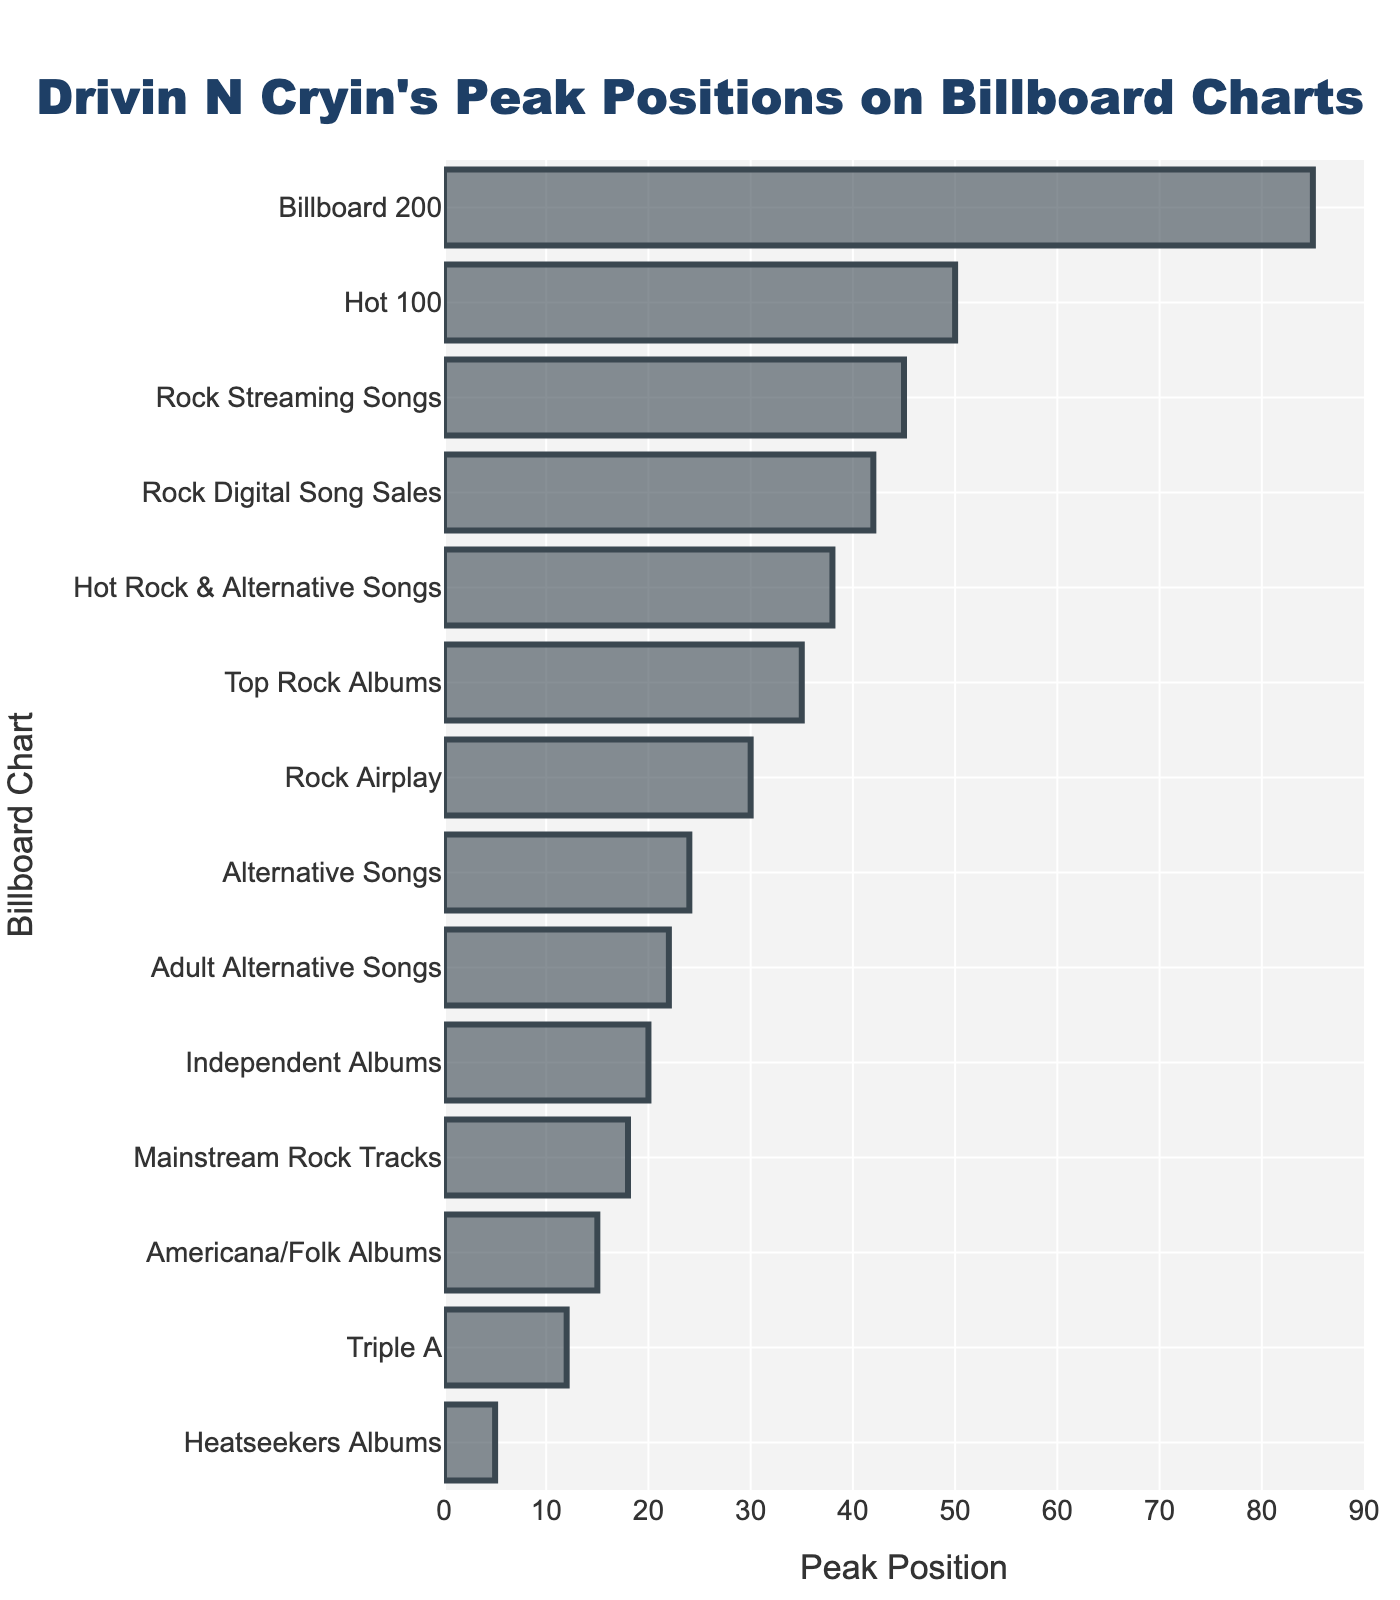What's the highest peak position Drivin N Cryin achieved on any Billboard chart? The highest peak position is indicated by the bar with the lowest numerical value. The chart with position 5 on "Heatseekers Albums" is the highest peak position.
Answer: 5 Which chart has the lowest peak position for Drivin N Cryin? The lowest peak position is indicated by the bar with the highest numerical value. The "Billboard 200" chart has the lowest peak position at 85.
Answer: Billboard 200 Compare the peak positions of "Alternative Songs" and "Hot Rock & Alternative Songs". Which one is higher? The "Alternative Songs" chart has a peak position of 24, while "Hot Rock & Alternative Songs" has a peak position of 38. The lower the number, the higher the position. Therefore, "Alternative Songs" is higher.
Answer: Alternative Songs What's the average peak position of the top three charts where Drivin N Cryin performed best? The top three charts are "Heatseekers Albums" (5), "Americana/Folk Albums" (15), and "Triple A" (12). The average is calculated as (5 + 12 + 15) / 3 = 32 / 3 ≈ 10.67.
Answer: 10.67 How many charts did Drivin N Cryin peak within the top 25 positions? Count the number of charts with peak positions of 25 or less. These are "Heatseekers Albums" (5), "Americana/Folk Albums" (15), "Triple A" (12), "Mainstream Rock Tracks" (18), and "Alternative Songs" (24). There are 5 such charts.
Answer: 5 Based on the chart positions, did Drivin N Cryin perform better on "Rock Digital Song Sales" or "Rock Streaming Songs"? Compare the peak positions: "Rock Digital Song Sales" at 42 and "Rock Streaming Songs" at 45. The lower the number, the better the performance. So, "Rock Digital Song Sales" is better.
Answer: Rock Digital Song Sales What's the difference in peak positions between "Rock Airplay" and "Mainstream Rock Tracks"? The peak position for "Rock Airplay" is 30, and for "Mainstream Rock Tracks" it is 18. The difference is calculated as 30 - 18 = 12.
Answer: 12 Which chart is visually positioned closest to the middle of the bar chart (in terms of peak position)? Identify the bar that is visually closest to the midpoint between the highest (85) and lowest (5) peak positions, which is (85 + 5) / 2 = 45. The chart "Rock Digital Song Sales" with a peak position of 42 is closest.
Answer: Rock Digital Song Sales What's the sum of the peak positions of Drivin N Cryin's top three worst-performing charts? The three peak positions are "Billboard 200" (85), "Rock Streaming Songs" (45), and "Hot Rock & Alternative Songs" (38). The sum is calculated as 85 + 45 + 38 = 168.
Answer: 168 